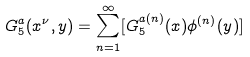Convert formula to latex. <formula><loc_0><loc_0><loc_500><loc_500>G _ { 5 } ^ { a } ( x ^ { \nu } , y ) = \sum _ { n = 1 } ^ { \infty } [ G _ { 5 } ^ { a ( n ) } ( x ) \phi ^ { ( n ) } ( y ) ]</formula> 